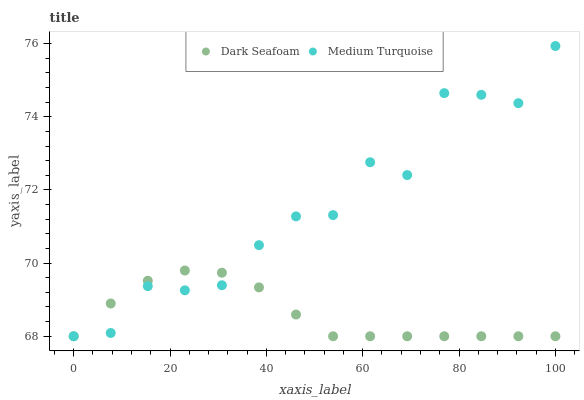Does Dark Seafoam have the minimum area under the curve?
Answer yes or no. Yes. Does Medium Turquoise have the maximum area under the curve?
Answer yes or no. Yes. Does Medium Turquoise have the minimum area under the curve?
Answer yes or no. No. Is Dark Seafoam the smoothest?
Answer yes or no. Yes. Is Medium Turquoise the roughest?
Answer yes or no. Yes. Is Medium Turquoise the smoothest?
Answer yes or no. No. Does Dark Seafoam have the lowest value?
Answer yes or no. Yes. Does Medium Turquoise have the highest value?
Answer yes or no. Yes. Does Medium Turquoise intersect Dark Seafoam?
Answer yes or no. Yes. Is Medium Turquoise less than Dark Seafoam?
Answer yes or no. No. Is Medium Turquoise greater than Dark Seafoam?
Answer yes or no. No. 